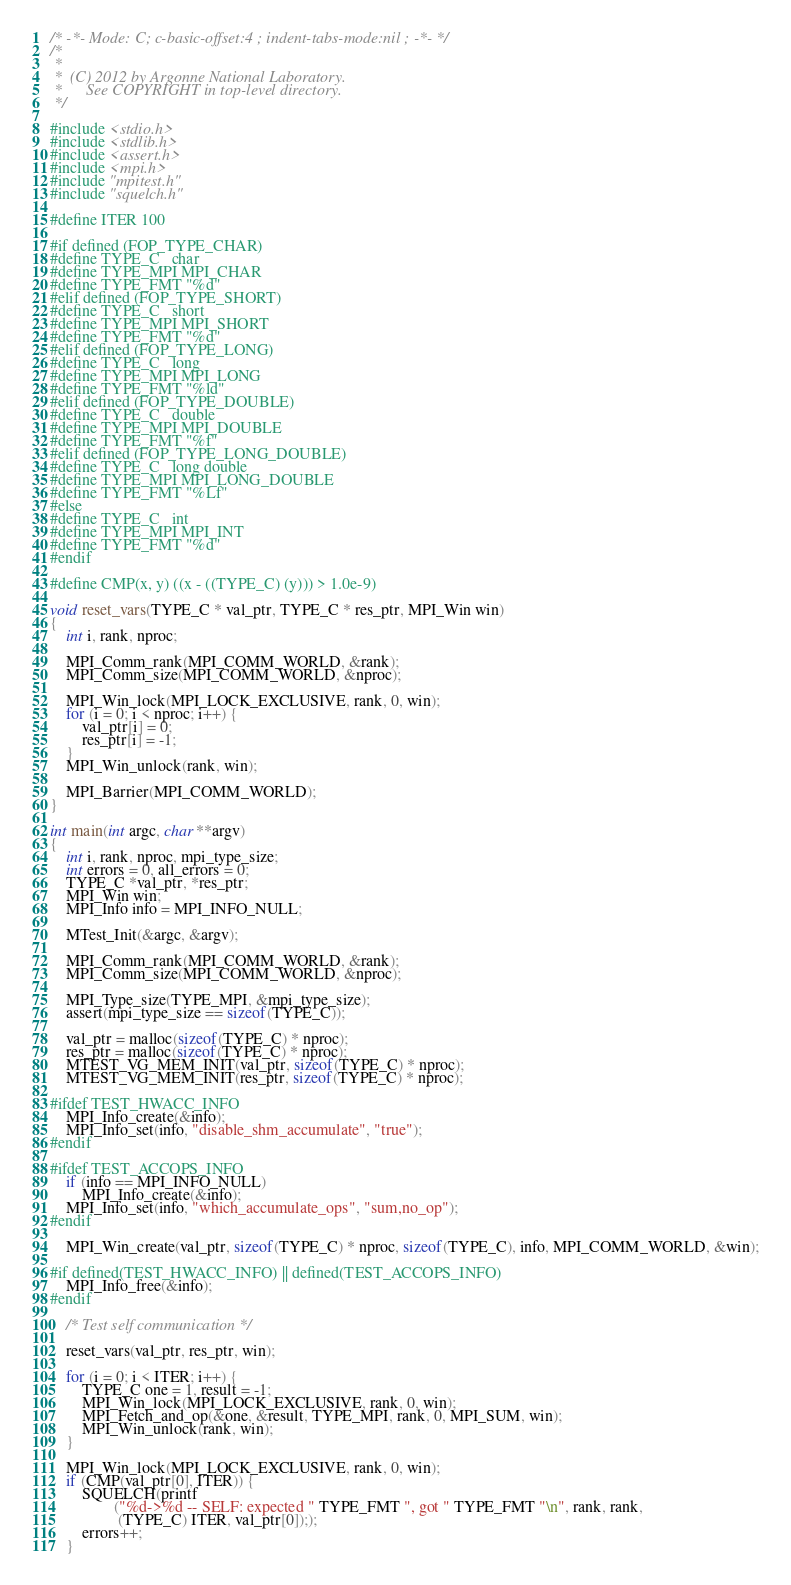Convert code to text. <code><loc_0><loc_0><loc_500><loc_500><_C_>/* -*- Mode: C; c-basic-offset:4 ; indent-tabs-mode:nil ; -*- */
/*
 *
 *  (C) 2012 by Argonne National Laboratory.
 *      See COPYRIGHT in top-level directory.
 */

#include <stdio.h>
#include <stdlib.h>
#include <assert.h>
#include <mpi.h>
#include "mpitest.h"
#include "squelch.h"

#define ITER 100

#if defined (FOP_TYPE_CHAR)
#define TYPE_C   char
#define TYPE_MPI MPI_CHAR
#define TYPE_FMT "%d"
#elif defined (FOP_TYPE_SHORT)
#define TYPE_C   short
#define TYPE_MPI MPI_SHORT
#define TYPE_FMT "%d"
#elif defined (FOP_TYPE_LONG)
#define TYPE_C   long
#define TYPE_MPI MPI_LONG
#define TYPE_FMT "%ld"
#elif defined (FOP_TYPE_DOUBLE)
#define TYPE_C   double
#define TYPE_MPI MPI_DOUBLE
#define TYPE_FMT "%f"
#elif defined (FOP_TYPE_LONG_DOUBLE)
#define TYPE_C   long double
#define TYPE_MPI MPI_LONG_DOUBLE
#define TYPE_FMT "%Lf"
#else
#define TYPE_C   int
#define TYPE_MPI MPI_INT
#define TYPE_FMT "%d"
#endif

#define CMP(x, y) ((x - ((TYPE_C) (y))) > 1.0e-9)

void reset_vars(TYPE_C * val_ptr, TYPE_C * res_ptr, MPI_Win win)
{
    int i, rank, nproc;

    MPI_Comm_rank(MPI_COMM_WORLD, &rank);
    MPI_Comm_size(MPI_COMM_WORLD, &nproc);

    MPI_Win_lock(MPI_LOCK_EXCLUSIVE, rank, 0, win);
    for (i = 0; i < nproc; i++) {
        val_ptr[i] = 0;
        res_ptr[i] = -1;
    }
    MPI_Win_unlock(rank, win);

    MPI_Barrier(MPI_COMM_WORLD);
}

int main(int argc, char **argv)
{
    int i, rank, nproc, mpi_type_size;
    int errors = 0, all_errors = 0;
    TYPE_C *val_ptr, *res_ptr;
    MPI_Win win;
    MPI_Info info = MPI_INFO_NULL;

    MTest_Init(&argc, &argv);

    MPI_Comm_rank(MPI_COMM_WORLD, &rank);
    MPI_Comm_size(MPI_COMM_WORLD, &nproc);

    MPI_Type_size(TYPE_MPI, &mpi_type_size);
    assert(mpi_type_size == sizeof(TYPE_C));

    val_ptr = malloc(sizeof(TYPE_C) * nproc);
    res_ptr = malloc(sizeof(TYPE_C) * nproc);
    MTEST_VG_MEM_INIT(val_ptr, sizeof(TYPE_C) * nproc);
    MTEST_VG_MEM_INIT(res_ptr, sizeof(TYPE_C) * nproc);

#ifdef TEST_HWACC_INFO
    MPI_Info_create(&info);
    MPI_Info_set(info, "disable_shm_accumulate", "true");
#endif

#ifdef TEST_ACCOPS_INFO
    if (info == MPI_INFO_NULL)
        MPI_Info_create(&info);
    MPI_Info_set(info, "which_accumulate_ops", "sum,no_op");
#endif

    MPI_Win_create(val_ptr, sizeof(TYPE_C) * nproc, sizeof(TYPE_C), info, MPI_COMM_WORLD, &win);

#if defined(TEST_HWACC_INFO) || defined(TEST_ACCOPS_INFO)
    MPI_Info_free(&info);
#endif

    /* Test self communication */

    reset_vars(val_ptr, res_ptr, win);

    for (i = 0; i < ITER; i++) {
        TYPE_C one = 1, result = -1;
        MPI_Win_lock(MPI_LOCK_EXCLUSIVE, rank, 0, win);
        MPI_Fetch_and_op(&one, &result, TYPE_MPI, rank, 0, MPI_SUM, win);
        MPI_Win_unlock(rank, win);
    }

    MPI_Win_lock(MPI_LOCK_EXCLUSIVE, rank, 0, win);
    if (CMP(val_ptr[0], ITER)) {
        SQUELCH(printf
                ("%d->%d -- SELF: expected " TYPE_FMT ", got " TYPE_FMT "\n", rank, rank,
                 (TYPE_C) ITER, val_ptr[0]););
        errors++;
    }</code> 